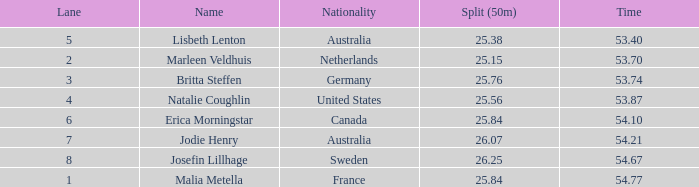What is the most sluggish 50m split time for a sum of 5 None. 